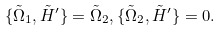Convert formula to latex. <formula><loc_0><loc_0><loc_500><loc_500>\{ \tilde { \Omega } _ { 1 } , \tilde { H } ^ { \prime } \} = \tilde { \Omega } _ { 2 } , \{ \tilde { \Omega } _ { 2 } , \tilde { H } ^ { \prime } \} = 0 .</formula> 